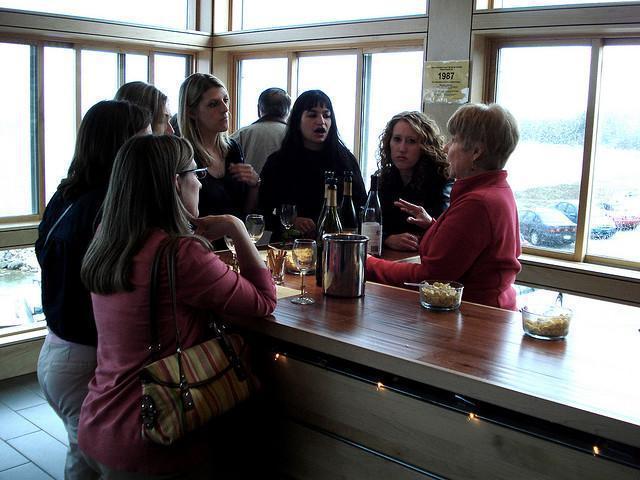What do the ladies here discuss?
Pick the right solution, then justify: 'Answer: answer
Rationale: rationale.'
Options: Anteaters, wine, women, retirement. Answer: wine.
Rationale: The ladies are near wine bottles. 